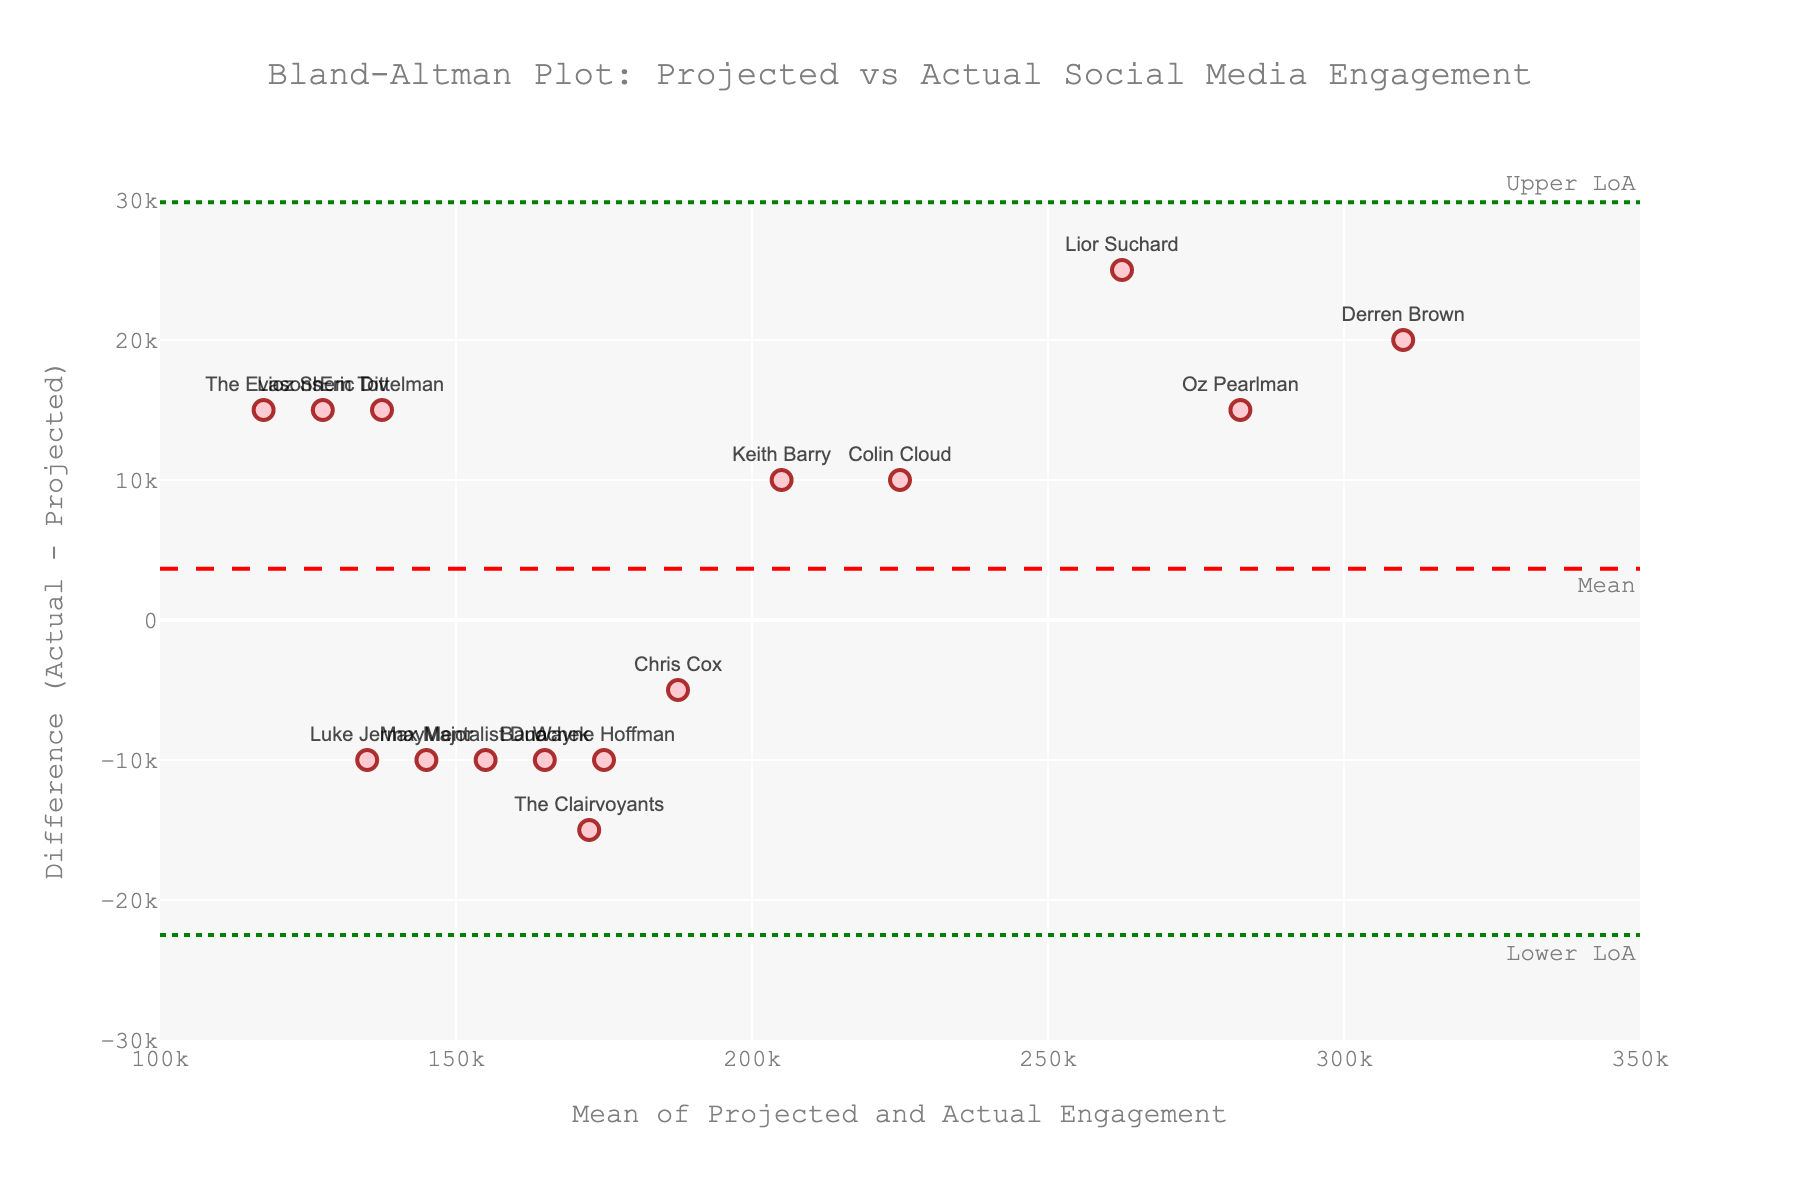Which performer has the highest mean engagement? Look for the data point with the highest x-value since the x-axis represents the mean of "Projected Engagement" and "Actual Engagement".
Answer: Derren Brown How many performers have a positive engagement difference (actual > projected)? Count the number of data points above the zero line on the y-axis, which indicates positive differences where actual engagement is greater than projected engagement.
Answer: 9 What are the upper and lower limits of agreement? Identify the green dotted lines representing the limits of agreement. Check the y-values of where these lines are annotated as "Upper LoA" and "Lower LoA".
Answer: 1616.0 and 23717.33 Which performer has the largest absolute difference between projected and actual engagement? Find the data point with the maximum distance from the zero line on the y-axis, regardless of direction, since it indicates the largest magnitude of discrepancy.
Answer: Lior Suchard What is the mean difference between actual and projected engagement? Locate the red dashed line annotated as "Mean" on the y-axis, which represents the average difference between actual and projected engagement.
Answer: 12791.67 Which performer has the most underestimated projected engagement (projected < actual) with the highest actual engagement? Identify the data points above the zero line that also have the highest x-values since these indicate underestimated projections with higher actual engagements.
Answer: Oz Pearlman How many performers have a lower actual engagement than projected engagement? Count the number of data points below the zero line, as these represent instances where the actual engagement is less than projected engagement.
Answer: 6 What is the lower bound of the x-axis? Check the lower limit labeled on the x-axis to determine its smallest value.
Answer: 100000 Do any performers exceed the upper limit of agreement, and if so, who? Find data points above the upper green dotted line annotated as "Upper LoA", indicating they exceed the upper limit of agreement.
Answer: No What is the y-value range of the plot? Determine the range by identifying the lowest and highest values labeled and visible on the y-axis.
Answer: -30000 to 30000 